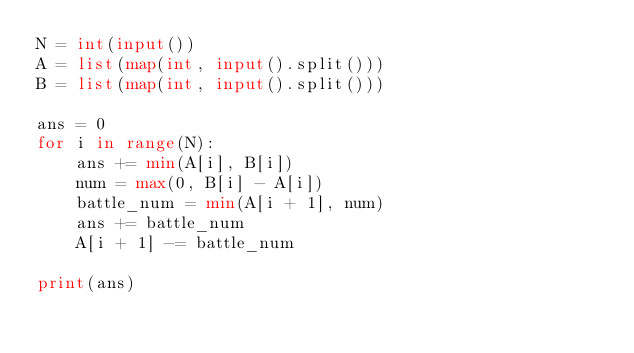<code> <loc_0><loc_0><loc_500><loc_500><_Python_>N = int(input())
A = list(map(int, input().split()))
B = list(map(int, input().split()))

ans = 0
for i in range(N):
    ans += min(A[i], B[i])
    num = max(0, B[i] - A[i])
    battle_num = min(A[i + 1], num)
    ans += battle_num
    A[i + 1] -= battle_num

print(ans)
</code> 